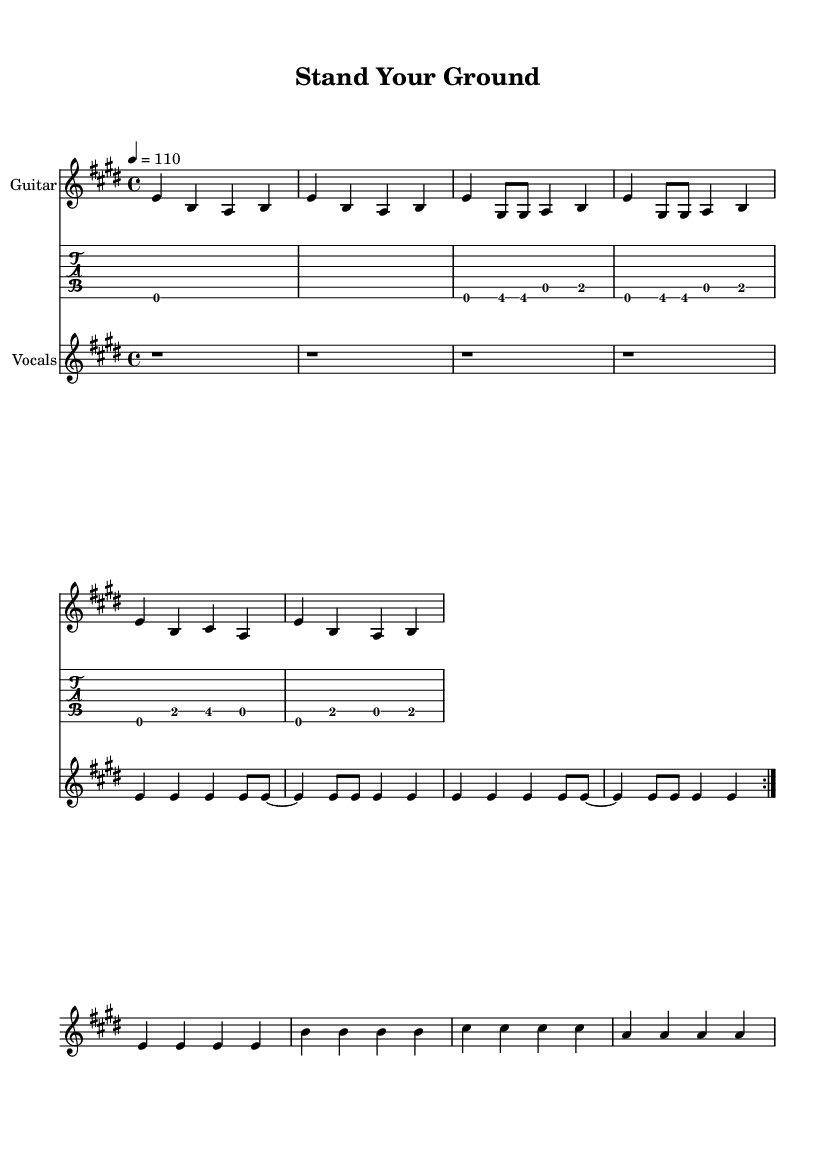What is the key signature of this music? The key signature is E major, which has four sharps represented by the sharp signs (F#, C#, G#, D#) in the key signature.
Answer: E major What is the time signature of this music? The time signature is 4/4, indicating four beats per measure, with a quarter note receiving one beat. This is evident in the time signature indicated in the header of the score.
Answer: 4/4 What is the tempo marking of this music? The tempo marking is 110 beats per minute, indicated at the beginning of the music after the tempo instruction "4 = 110." This shows the speed at which the piece should be played.
Answer: 110 How many times is the verse repeated before the chorus? The verse is repeated two times, as indicated by the repeat markings placed before the vocal line that begins with the lyrics. This is a common structure in many songs.
Answer: 2 What is the main lyrical theme expressed in the chorus? The chorus expresses a theme of resilience and determination, as it includes phrases like "Stand your ground, don't you fall, Rise above it all." This highlights the motivational aspect of the anthem.
Answer: Resilience What instruments are included in this piece? The piece includes guitar and vocals, as indicated by the staff labels and the music sections for each. The guitar plays both standard notation and tablature, while vocals are indicated separately.
Answer: Guitar and vocals Which section contains the lyrics about facing doubts and fears? The lyrics about facing doubts and fears can be found in the first verse, where it starts with "Faced with doubts and fears unknown." This sets up the emotional context of the song.
Answer: First verse 